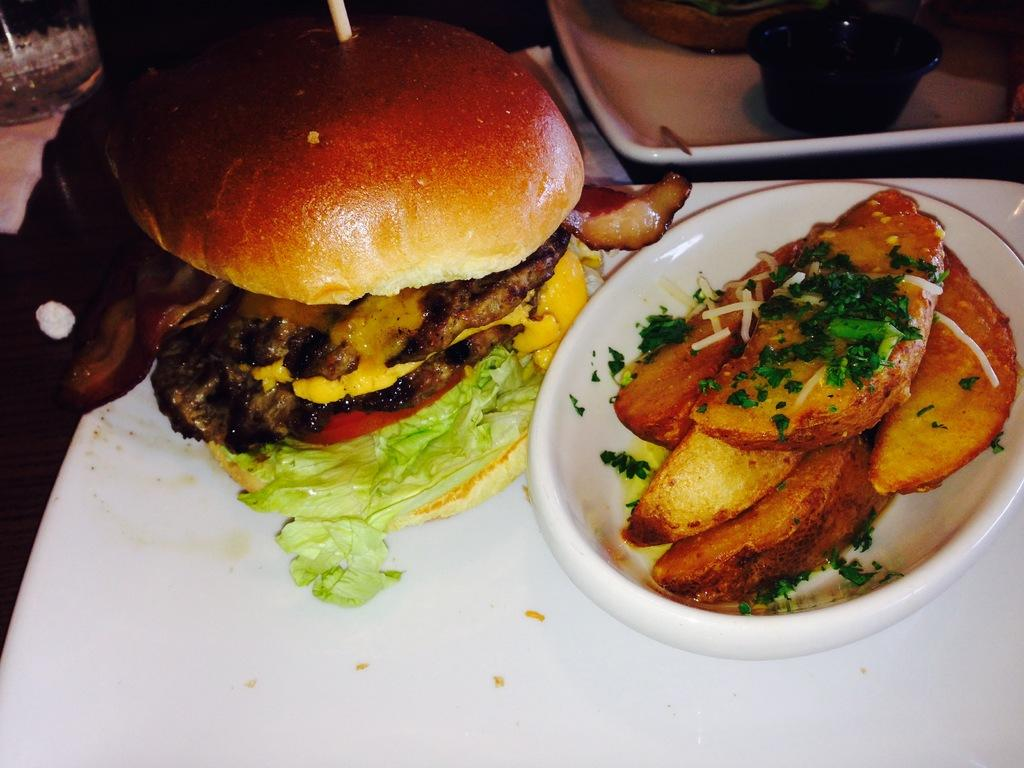What type of dishware is present in the image? There is a plate and bowls in the image. What is the food placed on in the image? The food is placed on a platform in the image. What type of mine can be seen in the image? There is no mine present in the image; it features a plate, bowls, and a platform with food. 